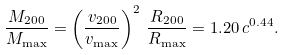<formula> <loc_0><loc_0><loc_500><loc_500>\frac { M _ { 2 0 0 } } { M _ { \max } } = \left ( \frac { v _ { 2 0 0 } } { v _ { \max } } \right ) ^ { 2 } \, \frac { R _ { 2 0 0 } } { R _ { \max } } = 1 . 2 0 \, c ^ { 0 . 4 4 } .</formula> 